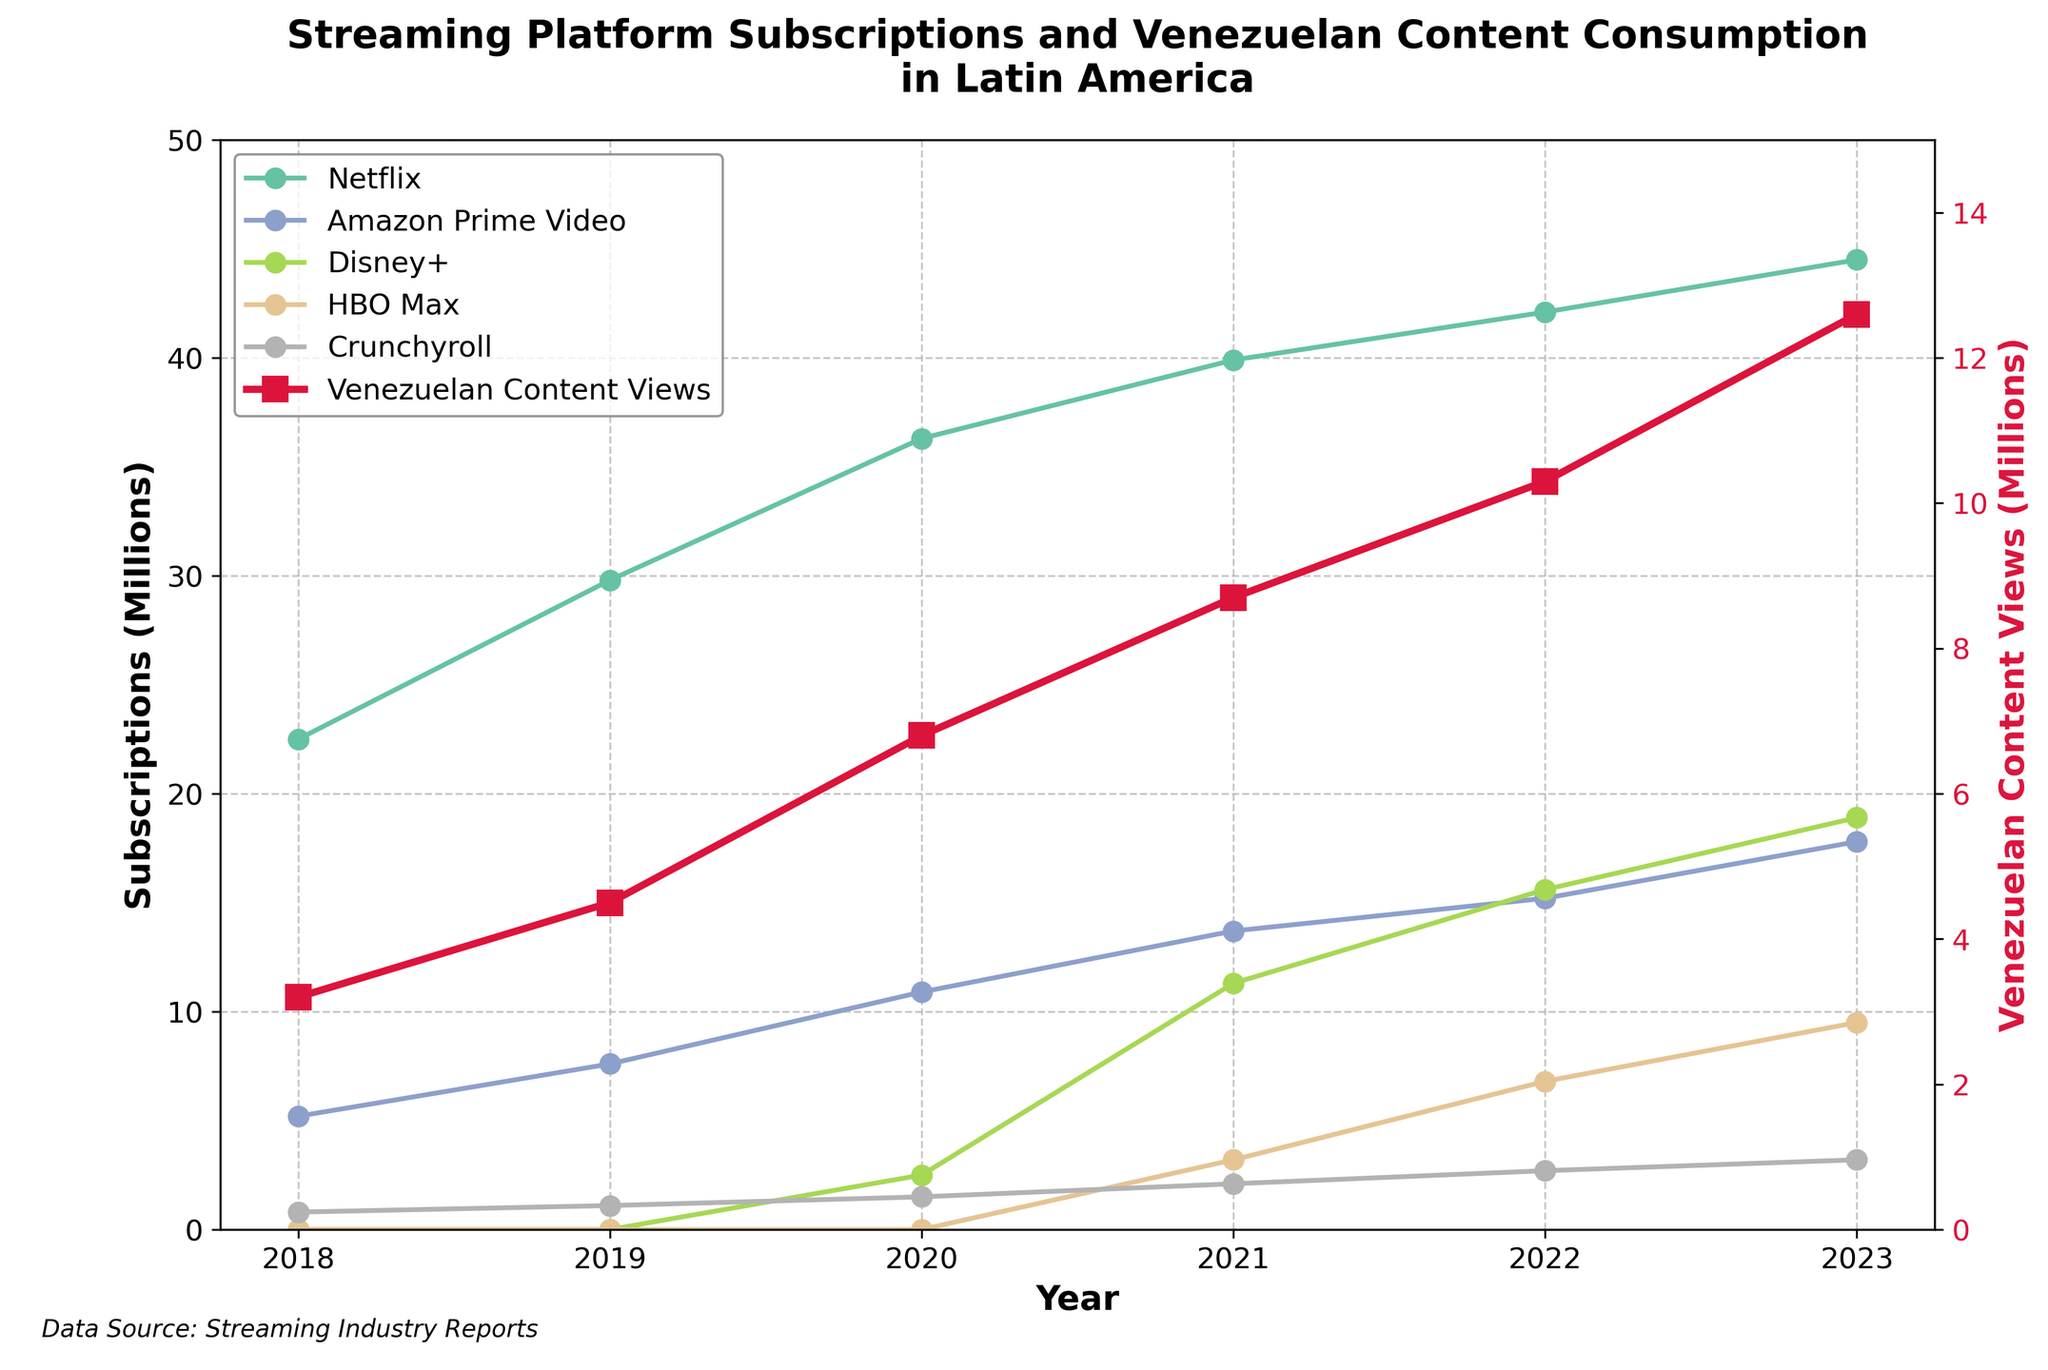What is the trend of Netflix subscriptions from 2018 to 2023? To identify the trend, observe the line plot for Netflix from 2018 to 2023. It starts at 22.5 million in 2018 and increases each year, reaching 44.5 million in 2023, indicating a consistent upward trend.
Answer: Upward trend Which year did Disney+ subscriptions surpass 10 million? To find the year Disney+ subscriptions surpassed 10 million, examine the line corresponding to Disney+. In 2021, the subscriptions were at 11.3 million, marking the year it surpassed 10 million.
Answer: 2021 How do Venezuelan Content Views compare to Crunchyroll subscriptions in 2023? Look at the data points for 2023. Venezuelan Content Views are at 12.6 million, while Crunchyroll subscriptions are at 3.2 million. Comparing these, Venezuelan Content Views are significantly higher than Crunchyroll subscriptions in 2023.
Answer: Venezuelan Content Views are higher What is the growth in Amazon Prime Video subscriptions from 2018 to 2023? Subtract the 2018 value from the 2023 value for Amazon Prime Video. In 2018, it was 5.2 million, and in 2023, it is 17.8 million. The growth is 17.8 - 5.2 = 12.6 million.
Answer: 12.6 million Compare the Venezuelan Content Views with HBO Max subscriptions in 2022. In 2022, Venezuelan Content Views are 10.3 million and HBO Max subscriptions are 6.8 million. Venezuelan Content Views are 10.3 - 6.8 = 3.5 million higher than HBO Max subscriptions.
Answer: 3.5 million higher What is the ratio of Disney+ subscriptions to Venezuelan Content Views in 2023? Look at the 2023 values for Disney+ (18.9 million) and Venezuelan Content Views (12.6 million). The ratio is 18.9 / 12.6.
Answer: 1.5 Which streaming platform had the fastest growth between 2019 and 2020? Calculate the difference in subscriptions for each platform between 2019 and 2020, then compare these values: Netflix (6.5), Amazon Prime Video (3.3), Disney+ (2.5), HBO Max (0), Crunchyroll (0.4). The platform with the greatest increase is Netflix (6.5).
Answer: Netflix How did the trend of HBO Max subscriptions evolve from 2020 to 2023? Examine the line for HBO Max starting in 2020 (0), moving to 2021 (3.2), then 2022 (6.8), and finally 2023 (9.5). This indicates a consistent increasing trend.
Answer: Upward trend What is the combined subscription count for Netflix and Disney+ in 2023? Add the 2023 subscriptions for Netflix (44.5 million) and Disney+ (18.9 million). The combined total is 44.5 + 18.9 = 63.4 million.
Answer: 63.4 million Calculate the average yearly growth of Venezuelan Content Views from 2018 to 2023. Calculate the total growth from 3.2 million in 2018 to 12.6 million in 2023, which is 12.6 - 3.2 = 9.4 million. There are 5 growth periods (2018-2019, 2019-2020, 2020-2021, 2021-2022, 2022-2023). The average growth per year is 9.4 / 5 = 1.88 million per year.
Answer: 1.88 million per year 